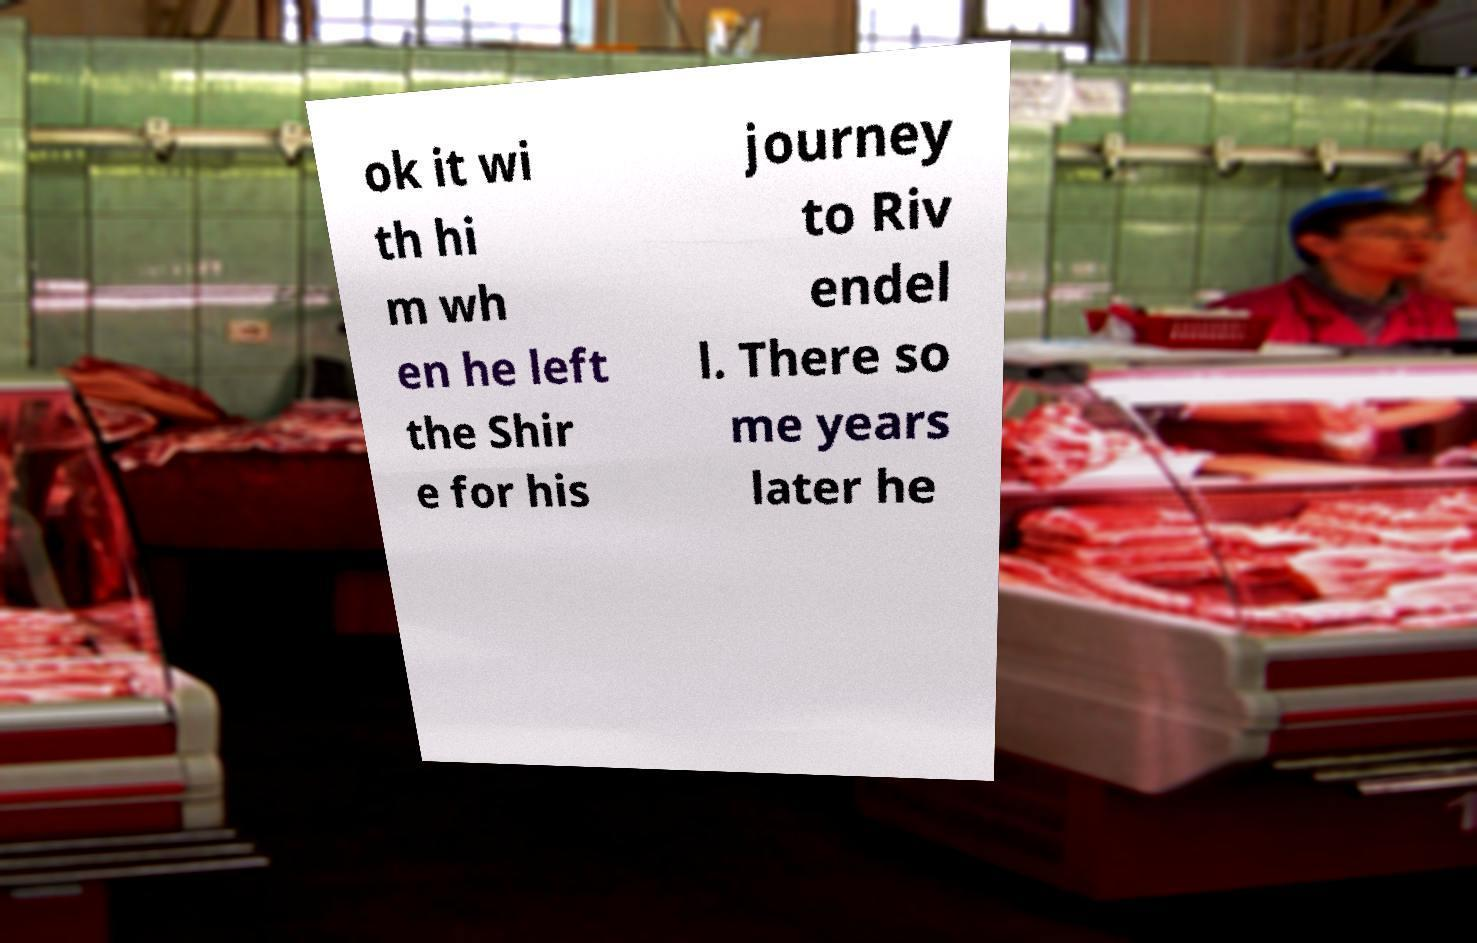Can you read and provide the text displayed in the image?This photo seems to have some interesting text. Can you extract and type it out for me? ok it wi th hi m wh en he left the Shir e for his journey to Riv endel l. There so me years later he 